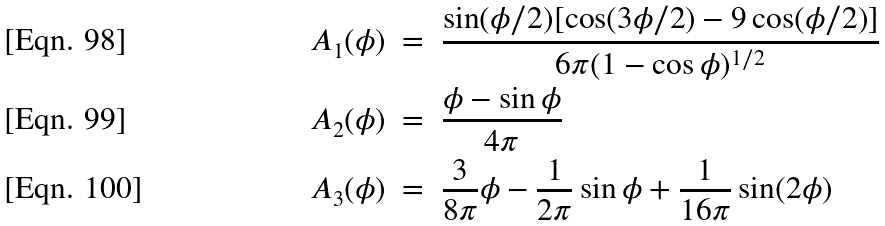Convert formula to latex. <formula><loc_0><loc_0><loc_500><loc_500>& A _ { 1 } ( \phi ) \ = \ \frac { \sin ( \phi / 2 ) [ \cos ( 3 \phi / 2 ) - 9 \cos ( \phi / 2 ) ] } { 6 \pi ( 1 - \cos \phi ) ^ { 1 / 2 } } \\ & A _ { 2 } ( \phi ) \ = \ \frac { \phi - \sin \phi } { 4 \pi } \\ & A _ { 3 } ( \phi ) \ = \ \frac { 3 } { 8 \pi } \phi - \frac { 1 } { 2 \pi } \sin \phi + \frac { 1 } { 1 6 \pi } \sin ( 2 \phi )</formula> 